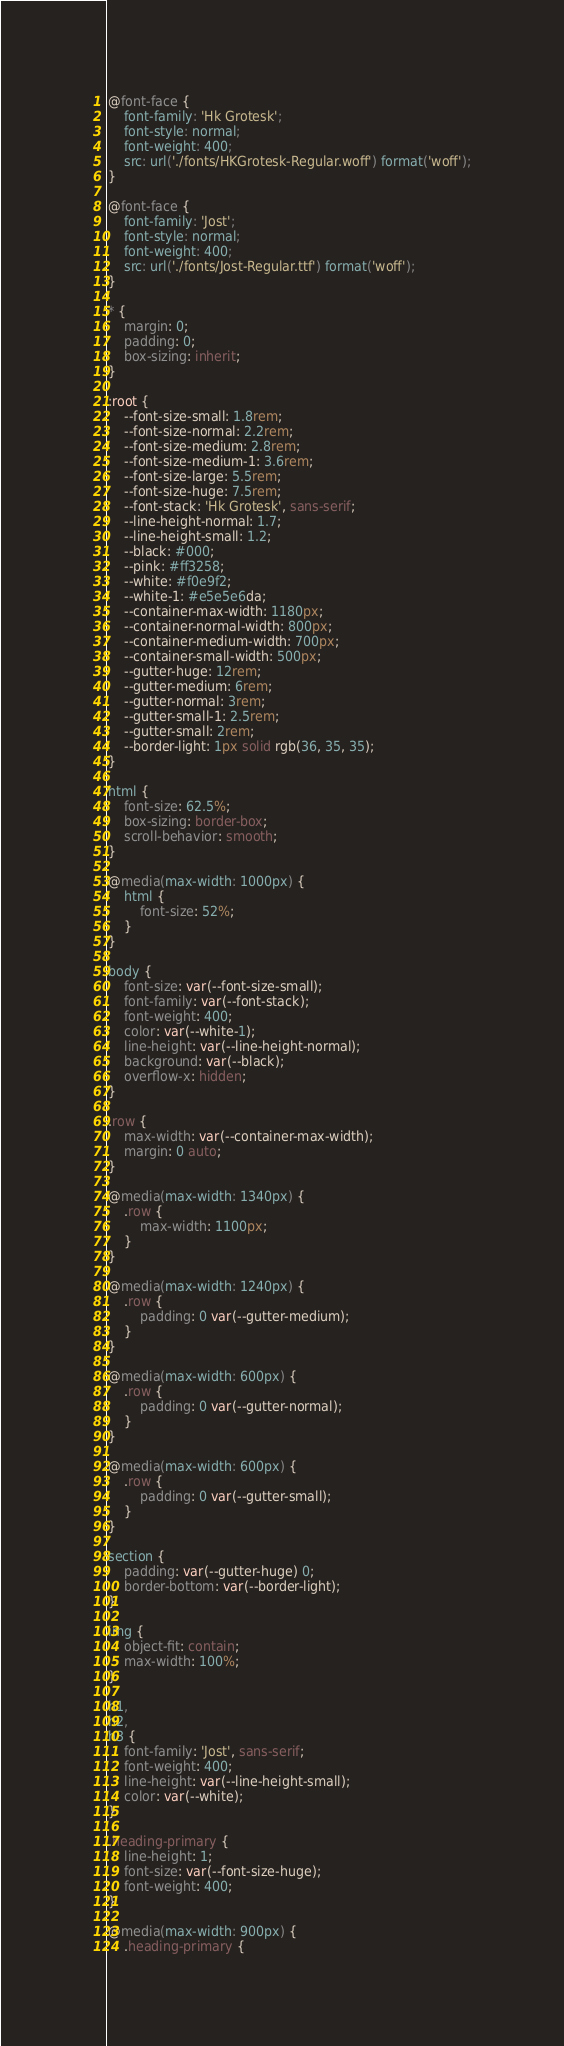<code> <loc_0><loc_0><loc_500><loc_500><_CSS_>@font-face {
    font-family: 'Hk Grotesk';
    font-style: normal;
    font-weight: 400;
    src: url('./fonts/HKGrotesk-Regular.woff') format('woff');
}

@font-face {
    font-family: 'Jost';
    font-style: normal;
    font-weight: 400;
    src: url('./fonts/Jost-Regular.ttf') format('woff');
}

* {
    margin: 0;
    padding: 0;
    box-sizing: inherit;
}

:root {
    --font-size-small: 1.8rem;
    --font-size-normal: 2.2rem;
    --font-size-medium: 2.8rem;
    --font-size-medium-1: 3.6rem;
    --font-size-large: 5.5rem;
    --font-size-huge: 7.5rem;
    --font-stack: 'Hk Grotesk', sans-serif;
    --line-height-normal: 1.7;
    --line-height-small: 1.2;
    --black: #000;
    --pink: #ff3258;
    --white: #f0e9f2;
    --white-1: #e5e5e6da;
    --container-max-width: 1180px;
    --container-normal-width: 800px;
    --container-medium-width: 700px;
    --container-small-width: 500px;
    --gutter-huge: 12rem;
    --gutter-medium: 6rem;
    --gutter-normal: 3rem;
    --gutter-small-1: 2.5rem;
    --gutter-small: 2rem;
    --border-light: 1px solid rgb(36, 35, 35);
}

html {
    font-size: 62.5%;
    box-sizing: border-box;
    scroll-behavior: smooth;
}

@media(max-width: 1000px) {
    html {
        font-size: 52%;
    }
}

body {
    font-size: var(--font-size-small);
    font-family: var(--font-stack);
    font-weight: 400;
    color: var(--white-1);
    line-height: var(--line-height-normal);
    background: var(--black);
    overflow-x: hidden;
}

.row {
    max-width: var(--container-max-width);
    margin: 0 auto;
}

@media(max-width: 1340px) {
    .row {
        max-width: 1100px;
    }
}

@media(max-width: 1240px) {
    .row {
        padding: 0 var(--gutter-medium);
    }
}

@media(max-width: 600px) {
    .row {
        padding: 0 var(--gutter-normal);
    }
}

@media(max-width: 600px) {
    .row {
        padding: 0 var(--gutter-small);
    }
}

section {
    padding: var(--gutter-huge) 0;
    border-bottom: var(--border-light);
}

img {
    object-fit: contain;
    max-width: 100%;
}

h1,
h2,
h3 {
    font-family: 'Jost', sans-serif;
    font-weight: 400;
    line-height: var(--line-height-small);
    color: var(--white);
}

.heading-primary {
    line-height: 1;
    font-size: var(--font-size-huge);
    font-weight: 400;
}

@media(max-width: 900px) {
    .heading-primary {</code> 